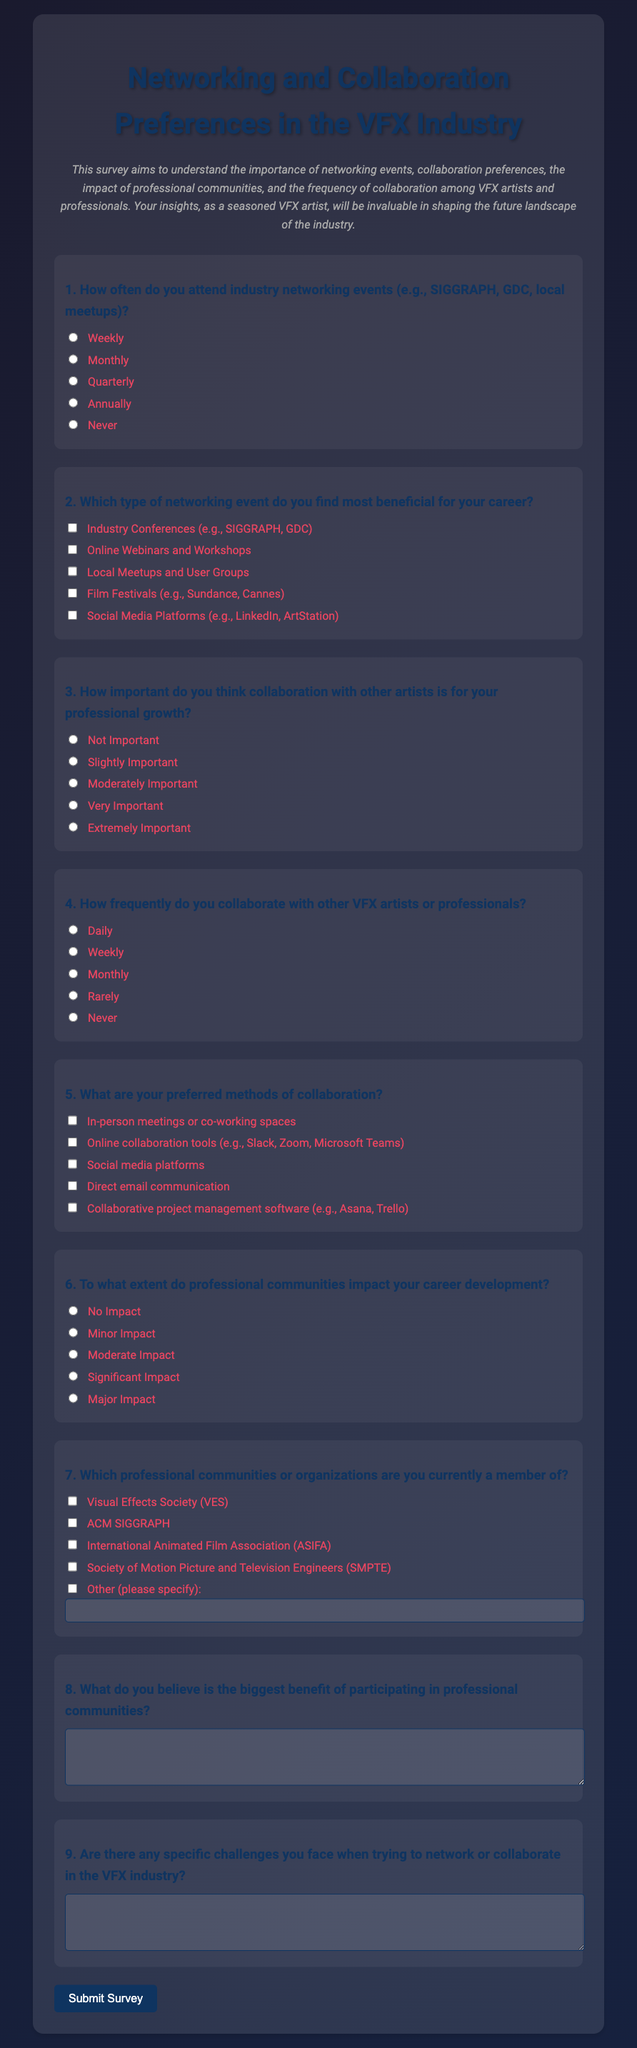how many questions are there in the survey? The document contains a total of 9 questions for the survey.
Answer: 9 what is the color scheme used in the document's background? The background employs a gradient color scheme transitioning from dark to lighter shades.
Answer: Gradient which professional community is listed as the last option in question 7? The last option in question 7 allows for specification of other professional communities not listed.
Answer: Other how frequently do VFX professionals collaborate, according to question 4? Question 4 provides options for varying frequencies of collaboration, such as daily and monthly.
Answer: Daily how is the survey title formatted in the document? The survey title is formatted as a large heading centered at the top of the document.
Answer: Centered heading what is the purpose of the survey described in the introduction? The survey aims to understand networking events and collaboration among VFX artists.
Answer: Understanding networking and collaboration what is the format for the response to question 8? Question 8 requests a textual response explaining the benefits of professional community participation.
Answer: Textual response how does the document instruct users to submit their responses? Users are instructed to submit their responses by clicking the "Submit Survey" button at the bottom.
Answer: Submit Survey button which type of collaboration method is mentioned first in question 5? The first collaboration method mentioned in question 5 is in-person meetings or co-working spaces.
Answer: In-person meetings 